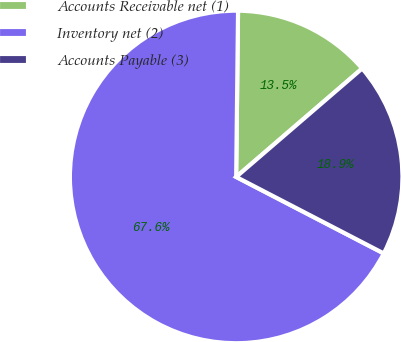Convert chart. <chart><loc_0><loc_0><loc_500><loc_500><pie_chart><fcel>Accounts Receivable net (1)<fcel>Inventory net (2)<fcel>Accounts Payable (3)<nl><fcel>13.51%<fcel>67.57%<fcel>18.92%<nl></chart> 